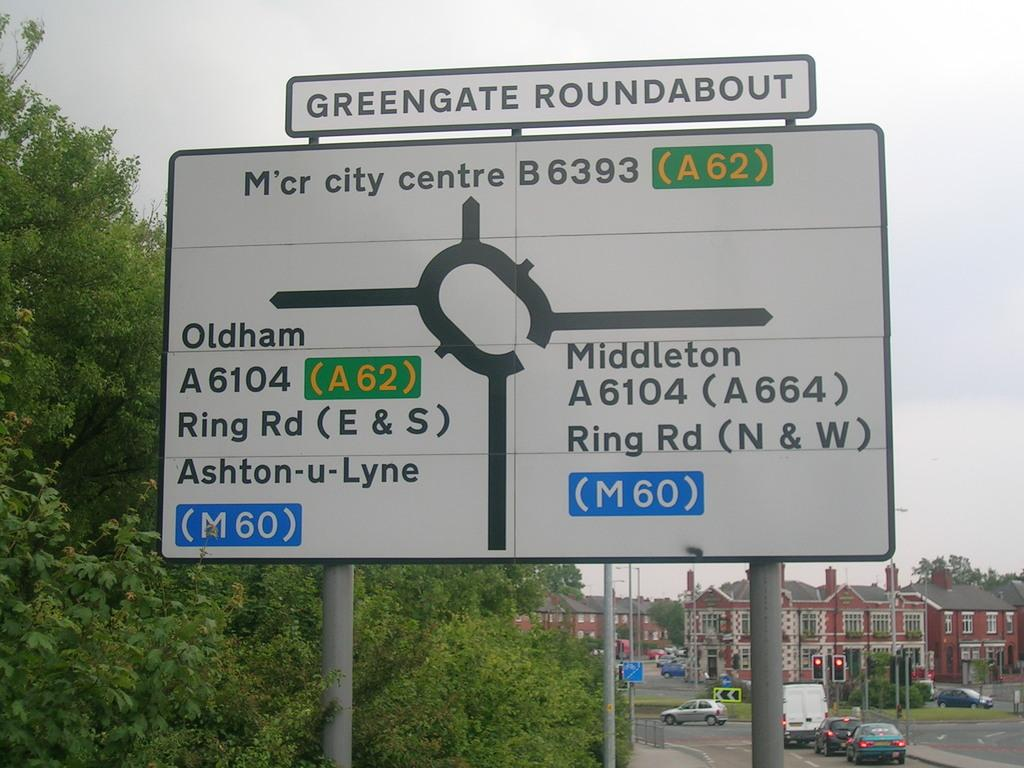<image>
Offer a succinct explanation of the picture presented. A sign shows the exits from the Greengate Roundabout. 